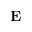<formula> <loc_0><loc_0><loc_500><loc_500>E</formula> 